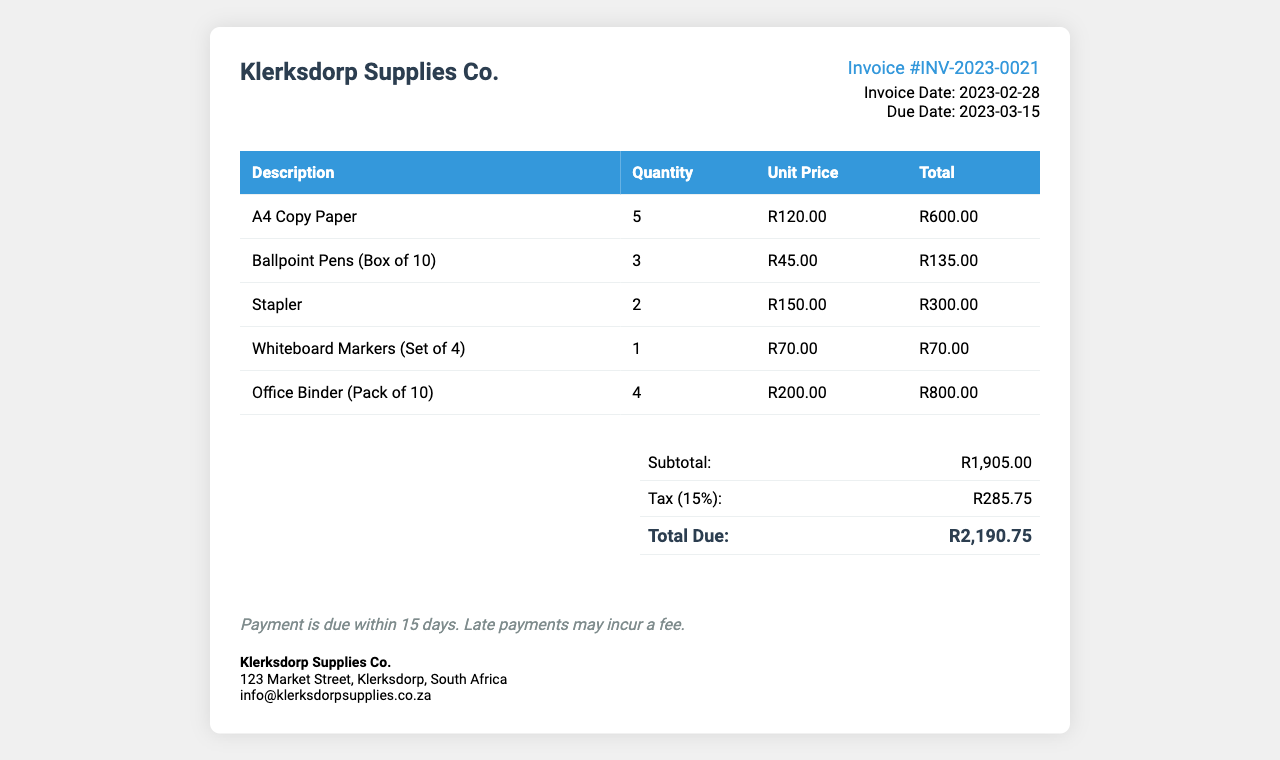What is the invoice number? The invoice number is displayed prominently in the document as #INV-2023-0021.
Answer: #INV-2023-0021 What is the invoice date? The document specifies the invoice date in the invoice details section, which is 2023-02-28.
Answer: 2023-02-28 How many A4 Copy Paper packs were purchased? The quantity of A4 Copy Paper packs purchased is indicated in the itemization table, which is 5.
Answer: 5 What is the total cost of the Office Binder? The total cost for the Office Binder is shown in the itemization, which amounts to R800.00.
Answer: R800.00 What is the subtotal before tax? The subtotal before tax is listed in the summary table as R1,905.00.
Answer: R1,905.00 What is the tax rate applied? The document states that the tax rate applied is 15%.
Answer: 15% How many different items are listed in the invoice? The number of different items is determined by counting the rows in the itemization table, which totals to 5.
Answer: 5 What is the total amount due? The total amount due is prominently highlighted in the summary table as R2,190.75.
Answer: R2,190.75 When is the payment due? The document details that the payment is due by 2023-03-15.
Answer: 2023-03-15 